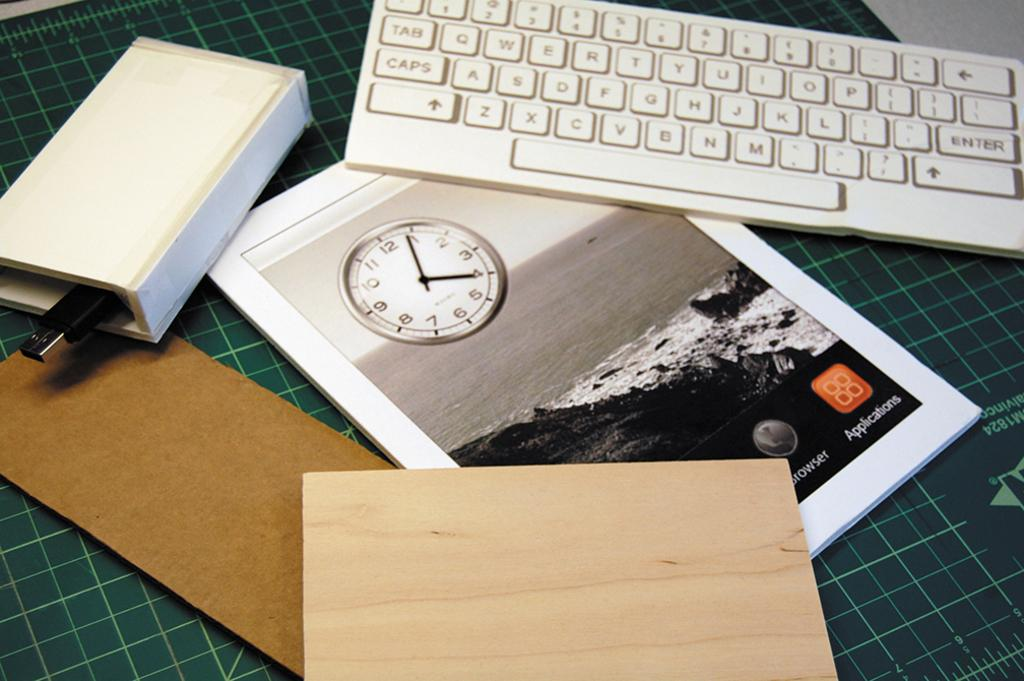<image>
Write a terse but informative summary of the picture. A keyboard, a piece of wood, and a printed page that says "Applications", all laying on a green desk. 